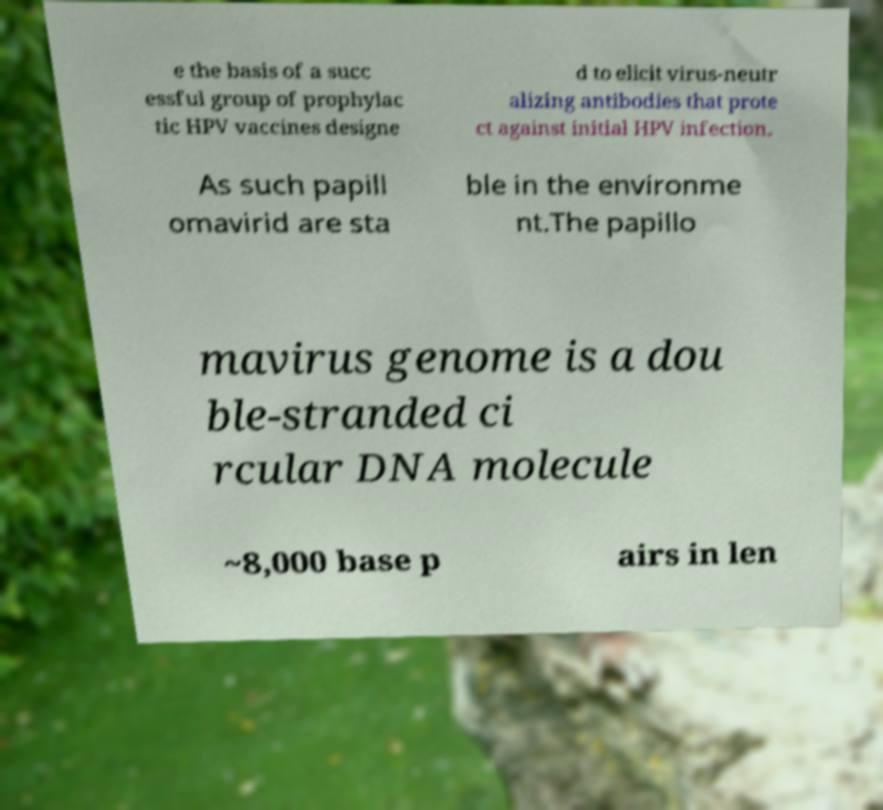I need the written content from this picture converted into text. Can you do that? e the basis of a succ essful group of prophylac tic HPV vaccines designe d to elicit virus-neutr alizing antibodies that prote ct against initial HPV infection. As such papill omavirid are sta ble in the environme nt.The papillo mavirus genome is a dou ble-stranded ci rcular DNA molecule ~8,000 base p airs in len 